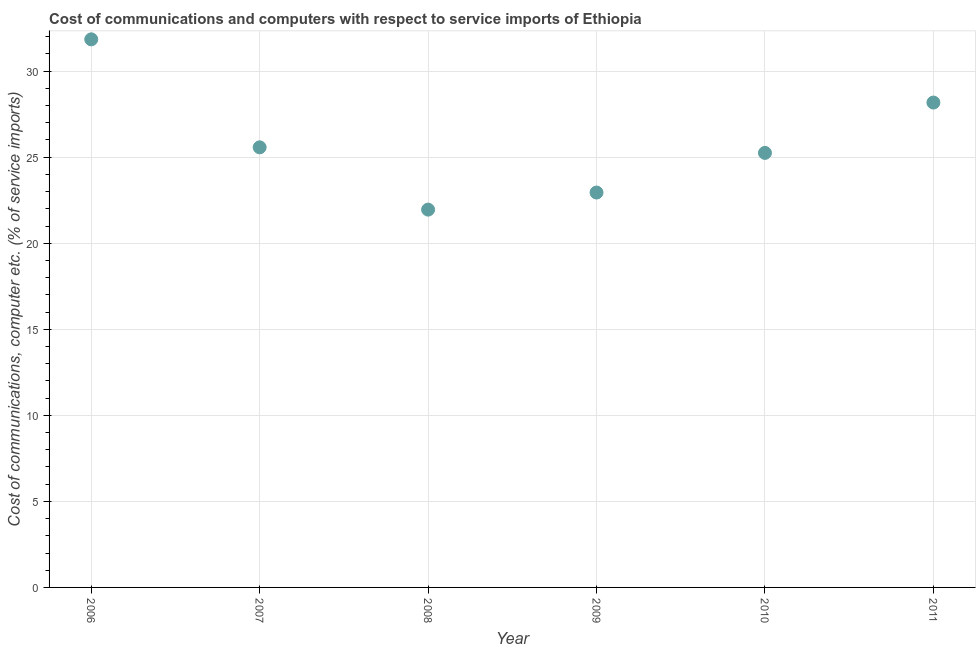What is the cost of communications and computer in 2007?
Make the answer very short. 25.57. Across all years, what is the maximum cost of communications and computer?
Provide a short and direct response. 31.85. Across all years, what is the minimum cost of communications and computer?
Offer a very short reply. 21.95. What is the sum of the cost of communications and computer?
Your answer should be compact. 155.73. What is the difference between the cost of communications and computer in 2007 and 2009?
Your answer should be compact. 2.63. What is the average cost of communications and computer per year?
Your answer should be very brief. 25.96. What is the median cost of communications and computer?
Your response must be concise. 25.41. In how many years, is the cost of communications and computer greater than 19 %?
Provide a short and direct response. 6. What is the ratio of the cost of communications and computer in 2009 to that in 2011?
Your response must be concise. 0.81. Is the cost of communications and computer in 2010 less than that in 2011?
Give a very brief answer. Yes. Is the difference between the cost of communications and computer in 2007 and 2008 greater than the difference between any two years?
Offer a terse response. No. What is the difference between the highest and the second highest cost of communications and computer?
Make the answer very short. 3.67. Is the sum of the cost of communications and computer in 2009 and 2011 greater than the maximum cost of communications and computer across all years?
Your answer should be compact. Yes. What is the difference between the highest and the lowest cost of communications and computer?
Offer a very short reply. 9.89. Does the cost of communications and computer monotonically increase over the years?
Ensure brevity in your answer.  No. How many dotlines are there?
Ensure brevity in your answer.  1. How many years are there in the graph?
Give a very brief answer. 6. What is the difference between two consecutive major ticks on the Y-axis?
Offer a terse response. 5. Are the values on the major ticks of Y-axis written in scientific E-notation?
Provide a short and direct response. No. Does the graph contain any zero values?
Provide a succinct answer. No. Does the graph contain grids?
Your answer should be very brief. Yes. What is the title of the graph?
Your response must be concise. Cost of communications and computers with respect to service imports of Ethiopia. What is the label or title of the X-axis?
Your response must be concise. Year. What is the label or title of the Y-axis?
Offer a very short reply. Cost of communications, computer etc. (% of service imports). What is the Cost of communications, computer etc. (% of service imports) in 2006?
Provide a short and direct response. 31.85. What is the Cost of communications, computer etc. (% of service imports) in 2007?
Offer a terse response. 25.57. What is the Cost of communications, computer etc. (% of service imports) in 2008?
Offer a terse response. 21.95. What is the Cost of communications, computer etc. (% of service imports) in 2009?
Offer a terse response. 22.94. What is the Cost of communications, computer etc. (% of service imports) in 2010?
Your response must be concise. 25.25. What is the Cost of communications, computer etc. (% of service imports) in 2011?
Your answer should be very brief. 28.17. What is the difference between the Cost of communications, computer etc. (% of service imports) in 2006 and 2007?
Your answer should be compact. 6.27. What is the difference between the Cost of communications, computer etc. (% of service imports) in 2006 and 2008?
Give a very brief answer. 9.89. What is the difference between the Cost of communications, computer etc. (% of service imports) in 2006 and 2009?
Your answer should be very brief. 8.9. What is the difference between the Cost of communications, computer etc. (% of service imports) in 2006 and 2010?
Your answer should be very brief. 6.6. What is the difference between the Cost of communications, computer etc. (% of service imports) in 2006 and 2011?
Your answer should be very brief. 3.67. What is the difference between the Cost of communications, computer etc. (% of service imports) in 2007 and 2008?
Give a very brief answer. 3.62. What is the difference between the Cost of communications, computer etc. (% of service imports) in 2007 and 2009?
Provide a short and direct response. 2.63. What is the difference between the Cost of communications, computer etc. (% of service imports) in 2007 and 2010?
Provide a short and direct response. 0.32. What is the difference between the Cost of communications, computer etc. (% of service imports) in 2007 and 2011?
Provide a short and direct response. -2.6. What is the difference between the Cost of communications, computer etc. (% of service imports) in 2008 and 2009?
Keep it short and to the point. -0.99. What is the difference between the Cost of communications, computer etc. (% of service imports) in 2008 and 2010?
Make the answer very short. -3.3. What is the difference between the Cost of communications, computer etc. (% of service imports) in 2008 and 2011?
Offer a very short reply. -6.22. What is the difference between the Cost of communications, computer etc. (% of service imports) in 2009 and 2010?
Give a very brief answer. -2.3. What is the difference between the Cost of communications, computer etc. (% of service imports) in 2009 and 2011?
Your answer should be compact. -5.23. What is the difference between the Cost of communications, computer etc. (% of service imports) in 2010 and 2011?
Offer a terse response. -2.93. What is the ratio of the Cost of communications, computer etc. (% of service imports) in 2006 to that in 2007?
Give a very brief answer. 1.25. What is the ratio of the Cost of communications, computer etc. (% of service imports) in 2006 to that in 2008?
Give a very brief answer. 1.45. What is the ratio of the Cost of communications, computer etc. (% of service imports) in 2006 to that in 2009?
Offer a terse response. 1.39. What is the ratio of the Cost of communications, computer etc. (% of service imports) in 2006 to that in 2010?
Offer a terse response. 1.26. What is the ratio of the Cost of communications, computer etc. (% of service imports) in 2006 to that in 2011?
Your response must be concise. 1.13. What is the ratio of the Cost of communications, computer etc. (% of service imports) in 2007 to that in 2008?
Offer a very short reply. 1.17. What is the ratio of the Cost of communications, computer etc. (% of service imports) in 2007 to that in 2009?
Provide a short and direct response. 1.11. What is the ratio of the Cost of communications, computer etc. (% of service imports) in 2007 to that in 2010?
Offer a very short reply. 1.01. What is the ratio of the Cost of communications, computer etc. (% of service imports) in 2007 to that in 2011?
Ensure brevity in your answer.  0.91. What is the ratio of the Cost of communications, computer etc. (% of service imports) in 2008 to that in 2010?
Make the answer very short. 0.87. What is the ratio of the Cost of communications, computer etc. (% of service imports) in 2008 to that in 2011?
Your answer should be compact. 0.78. What is the ratio of the Cost of communications, computer etc. (% of service imports) in 2009 to that in 2010?
Your response must be concise. 0.91. What is the ratio of the Cost of communications, computer etc. (% of service imports) in 2009 to that in 2011?
Offer a terse response. 0.81. What is the ratio of the Cost of communications, computer etc. (% of service imports) in 2010 to that in 2011?
Keep it short and to the point. 0.9. 